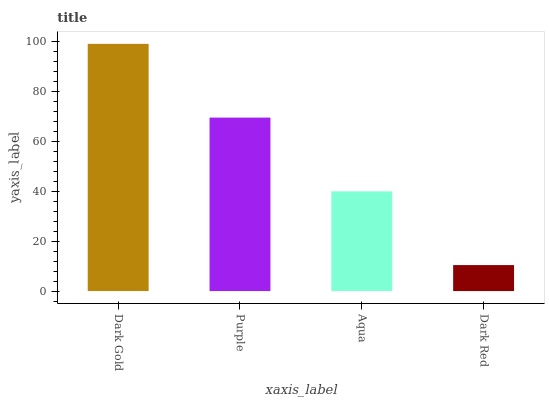Is Purple the minimum?
Answer yes or no. No. Is Purple the maximum?
Answer yes or no. No. Is Dark Gold greater than Purple?
Answer yes or no. Yes. Is Purple less than Dark Gold?
Answer yes or no. Yes. Is Purple greater than Dark Gold?
Answer yes or no. No. Is Dark Gold less than Purple?
Answer yes or no. No. Is Purple the high median?
Answer yes or no. Yes. Is Aqua the low median?
Answer yes or no. Yes. Is Dark Red the high median?
Answer yes or no. No. Is Dark Red the low median?
Answer yes or no. No. 